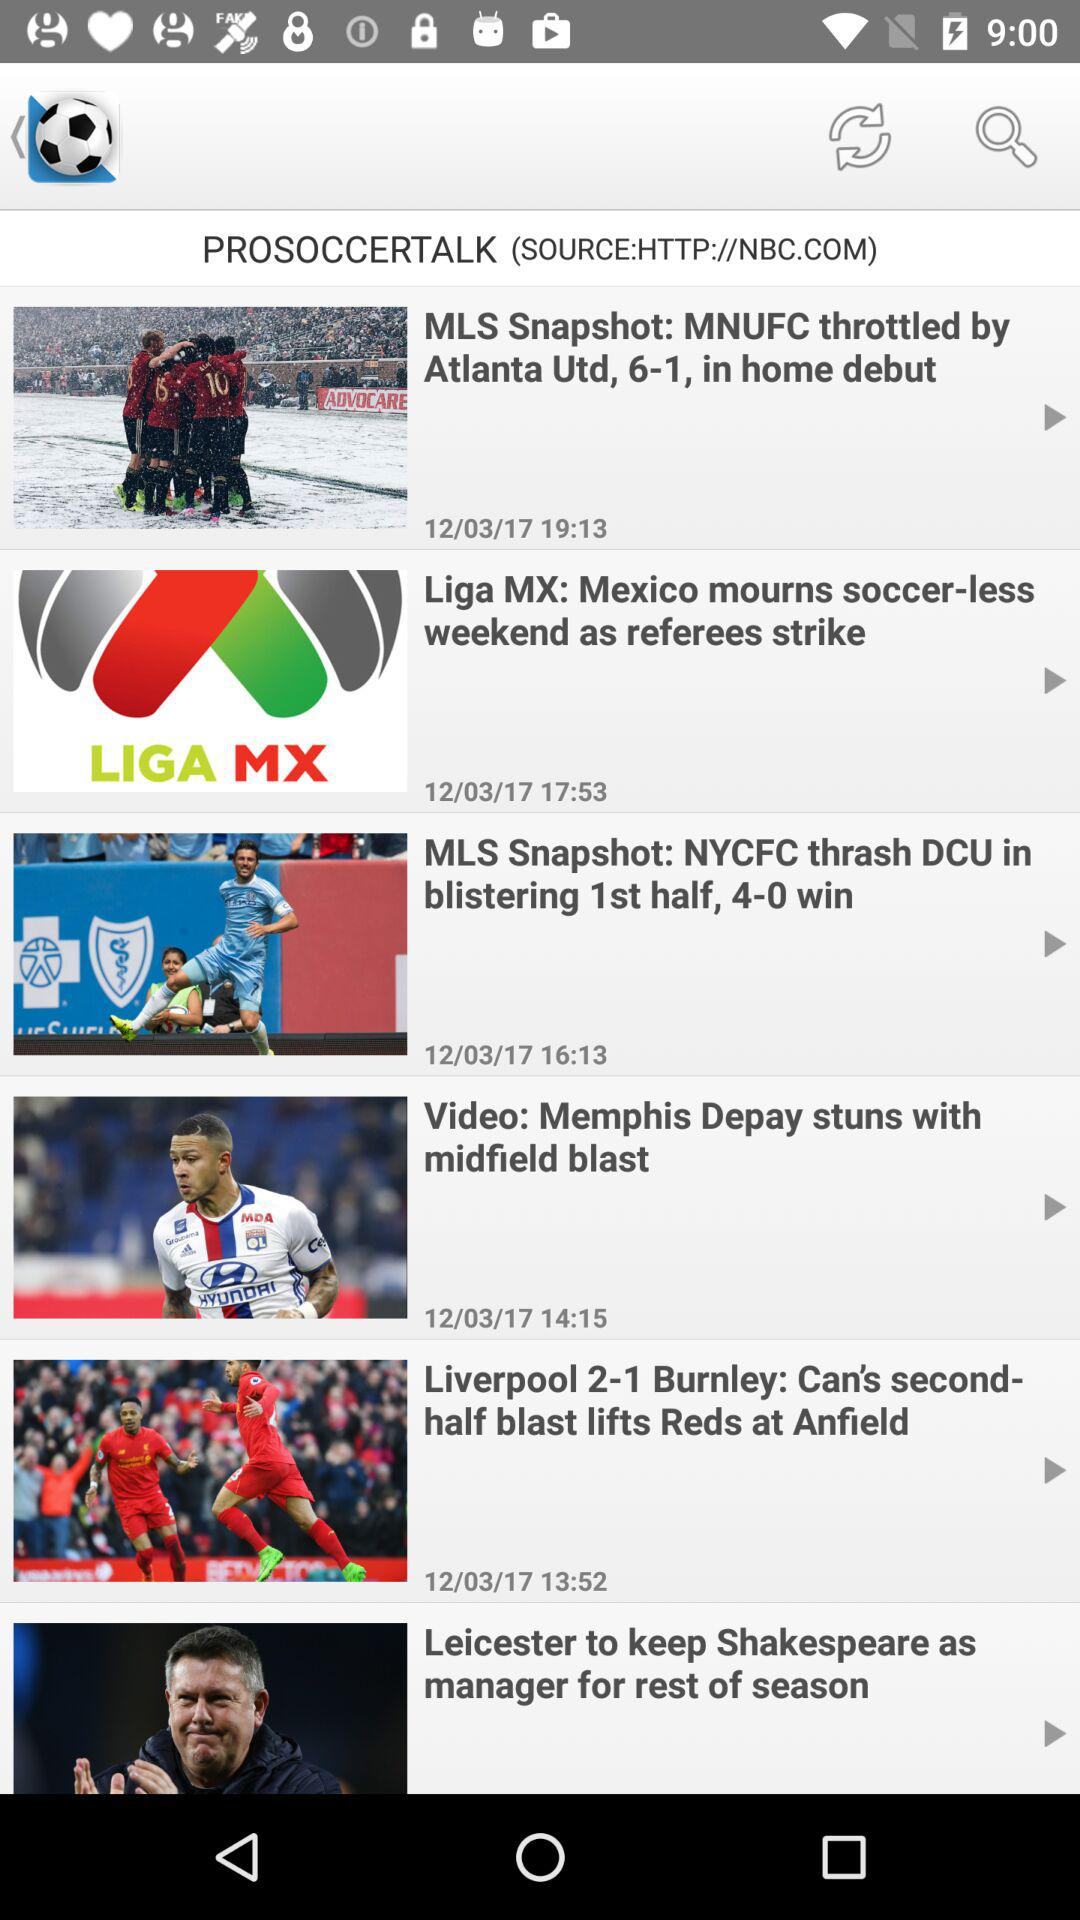What is the source of this news? The source is "HTTP://NBC.COM". 